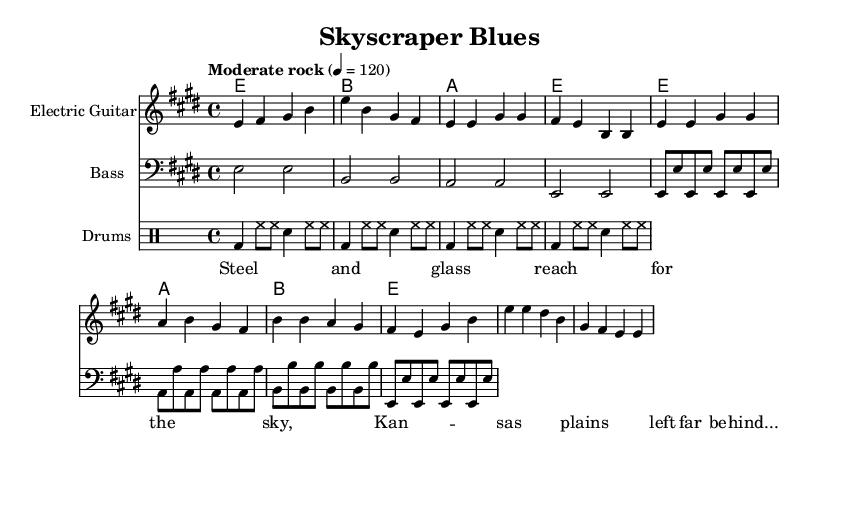What is the key signature of this music? The key signature is E major, indicated by the sharps at F# and C#.
Answer: E major What is the time signature of this music? The time signature is 4/4, meaning there are four beats in a measure.
Answer: 4/4 What is the tempo marking for this song? The tempo marking is "Moderate rock," which is specified at a quarter note equals 120 beats per minute.
Answer: Moderate rock How many measures are in the intro section for electric guitar? By counting the measures notated under the electric guitar part for the intro, there are 4 measures.
Answer: 4 measures What is the main chord progression used in the verse? The main chord progression in the verse alternates between E, A, and B chords.
Answer: E, A, B What are the first two words of the lyrics in the verse? The first two words of the lyrics are "Steel and" as seen in the lyric section.
Answer: Steel and Which instrument plays the bass clef part? The bass clef part is played by the bass guitar, as indicated by the clef notation at the beginning of the part.
Answer: Bass guitar 